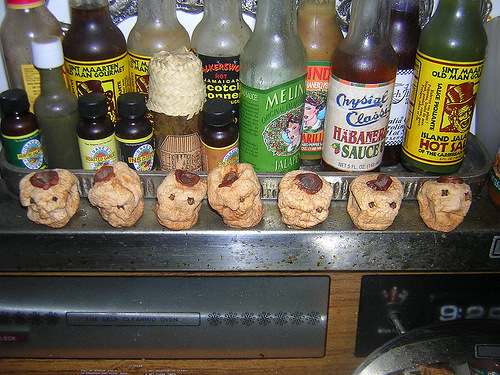<image>
Can you confirm if the bottle is in front of the bottle? Yes. The bottle is positioned in front of the bottle, appearing closer to the camera viewpoint. Where is the apple head in relation to the hot sauce? Is it in front of the hot sauce? No. The apple head is not in front of the hot sauce. The spatial positioning shows a different relationship between these objects. 